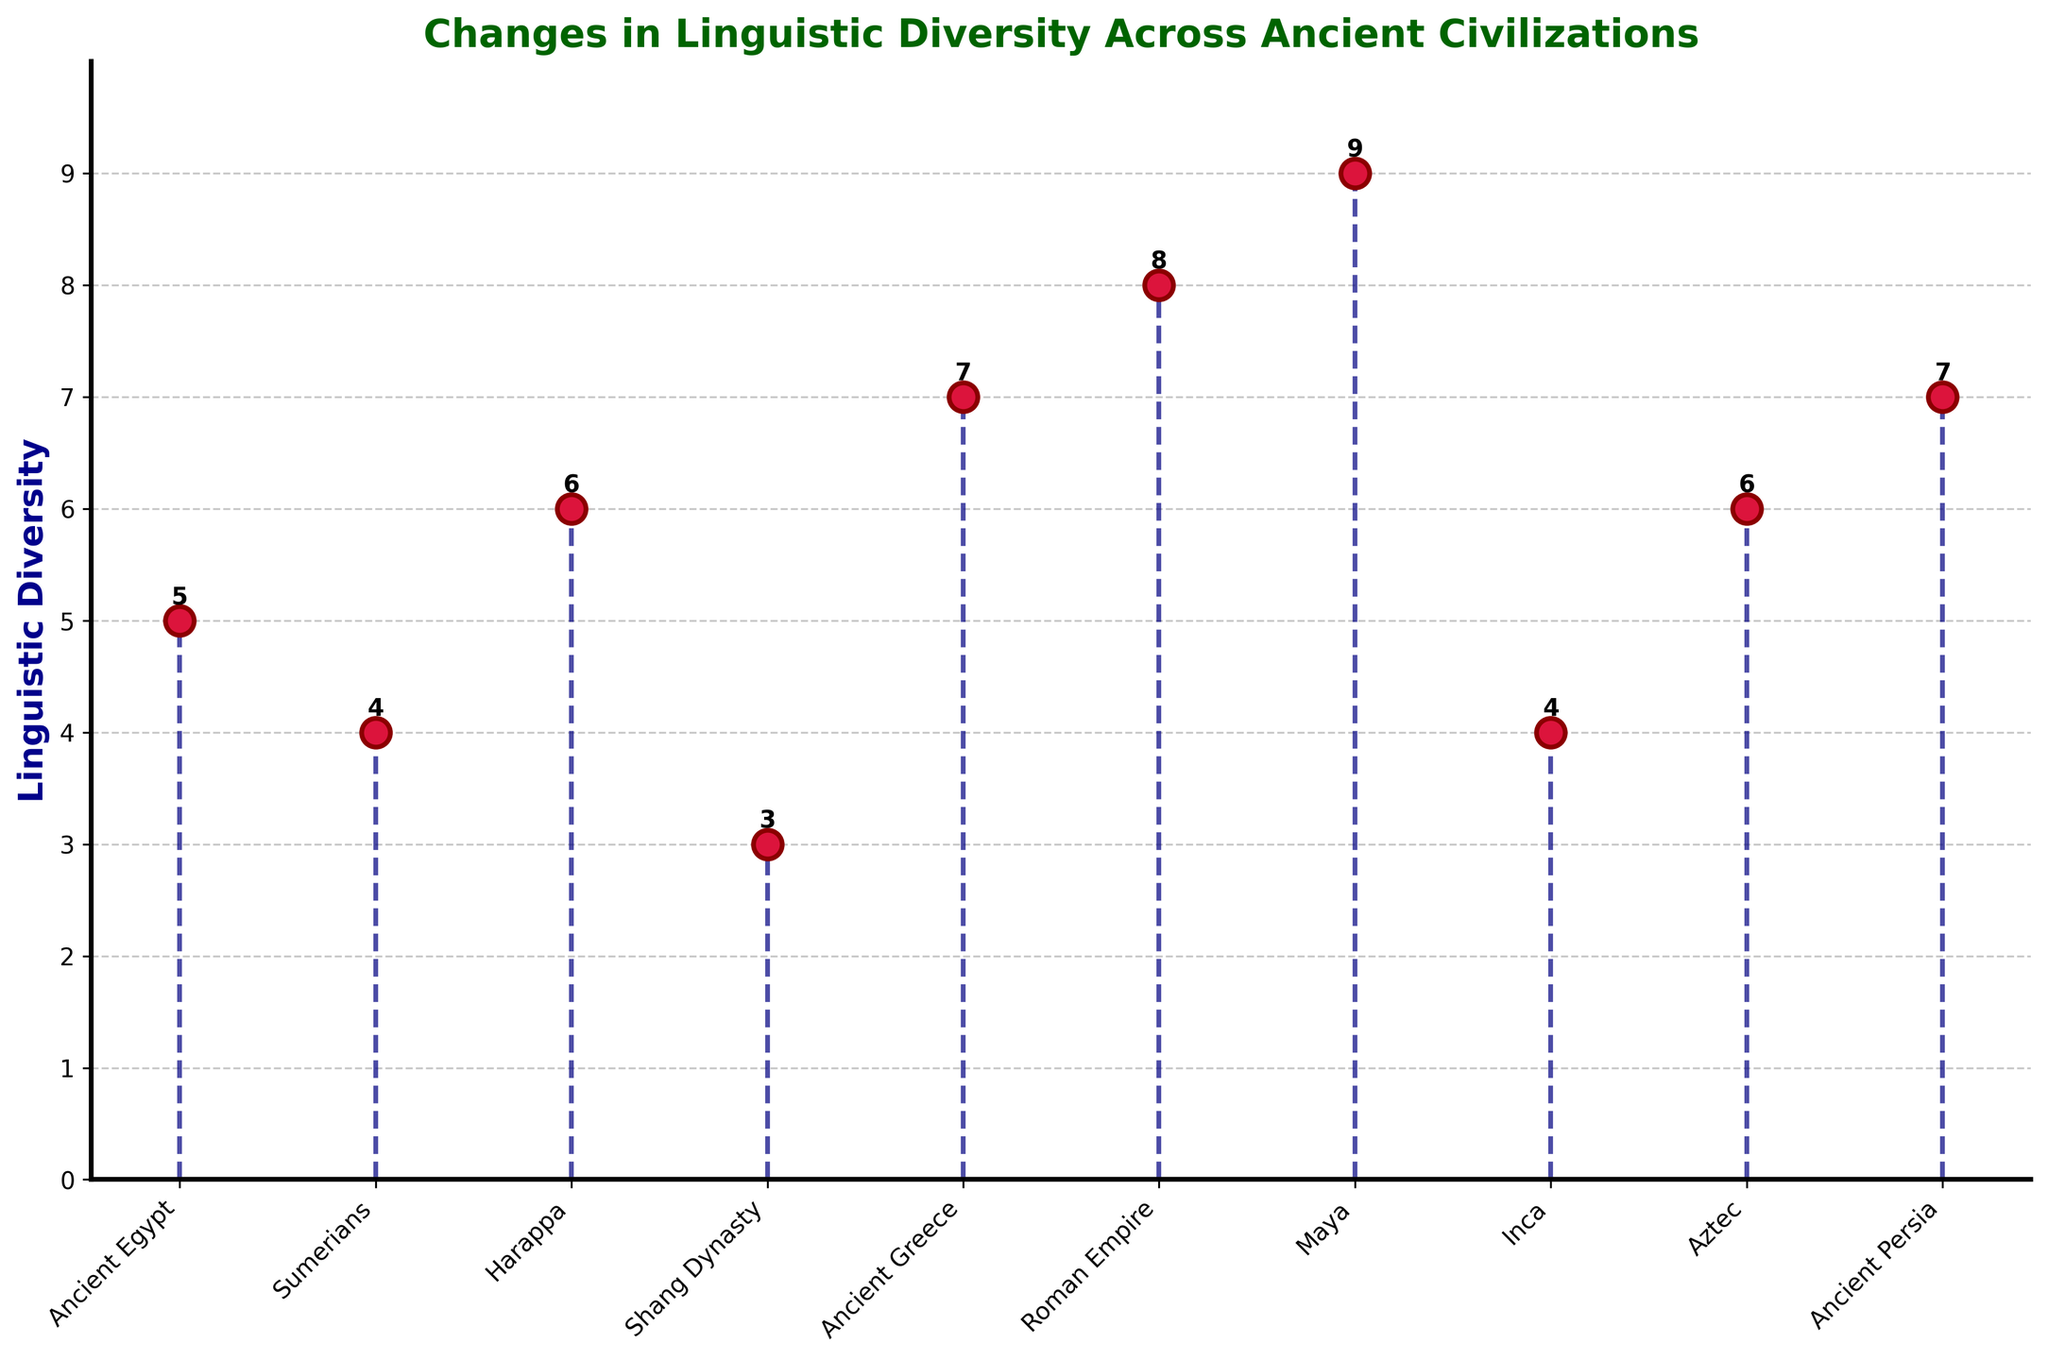What is the title of the figure? The title of the figure is at the top and clearly states the subject.
Answer: Changes in Linguistic Diversity Across Ancient Civilizations Which civilization has the highest linguistic diversity? Among all the data points, the civilization with the highest marker on the y-axis represents the highest linguistic diversity value.
Answer: Maya How many civilizations are represented in the figure? Count the number of markers or labels along the x-axis.
Answer: 10 What is the lowest value of linguistic diversity, and which civilization does it represent? Identify the smallest value on the y-axis and the corresponding civilization on the x-axis.
Answer: 3, Shang Dynasty What colors are used for the markers and stem lines? The markers are colored crimson with darkred edges, and the stem lines are colored navy.
Answer: Crimson for markers and navy for stem lines What is the average value of linguistic diversity across all civilizations? Sum the diversity values for all civilizations and divide by the total number of civilizations. (5 + 4 + 6 + 3 + 7 + 8 + 9 + 4 + 6 + 7) / 10 = 59 / 10 = 5.9
Answer: 5.9 What's the difference in linguistic diversity between the Maya and the Inca civilization? Subtract the linguistic diversity value of the Inca from that of the Maya. 9 (Maya) - 4 (Inca) = 5
Answer: 5 Which civilization has greater linguistic diversity, the Sumerians or the Aztec? Compare the diversity values: Sumerians (4) vs. Aztec (6).
Answer: Aztec Are there more civilizations with linguistic diversity values greater than 5 or less than or equal to 5? Count the number of civilizations with values > 5 and those with values ≤ 5. Greater than 5: 5 civilizations (Harappa, Ancient Greece, Roman Empire, Maya, Aztec, Ancient Persia), Less than or equal to 5: 4 civilizations (Ancient Egypt, Sumerians, Shang Dynasty, Inca).
Answer: Greater than 5 Which civilization is the third highest in terms of linguistic diversity? Drop down from the third highest marker on the y-axis to find the corresponding civilization.
Answer: Ancient Greece 